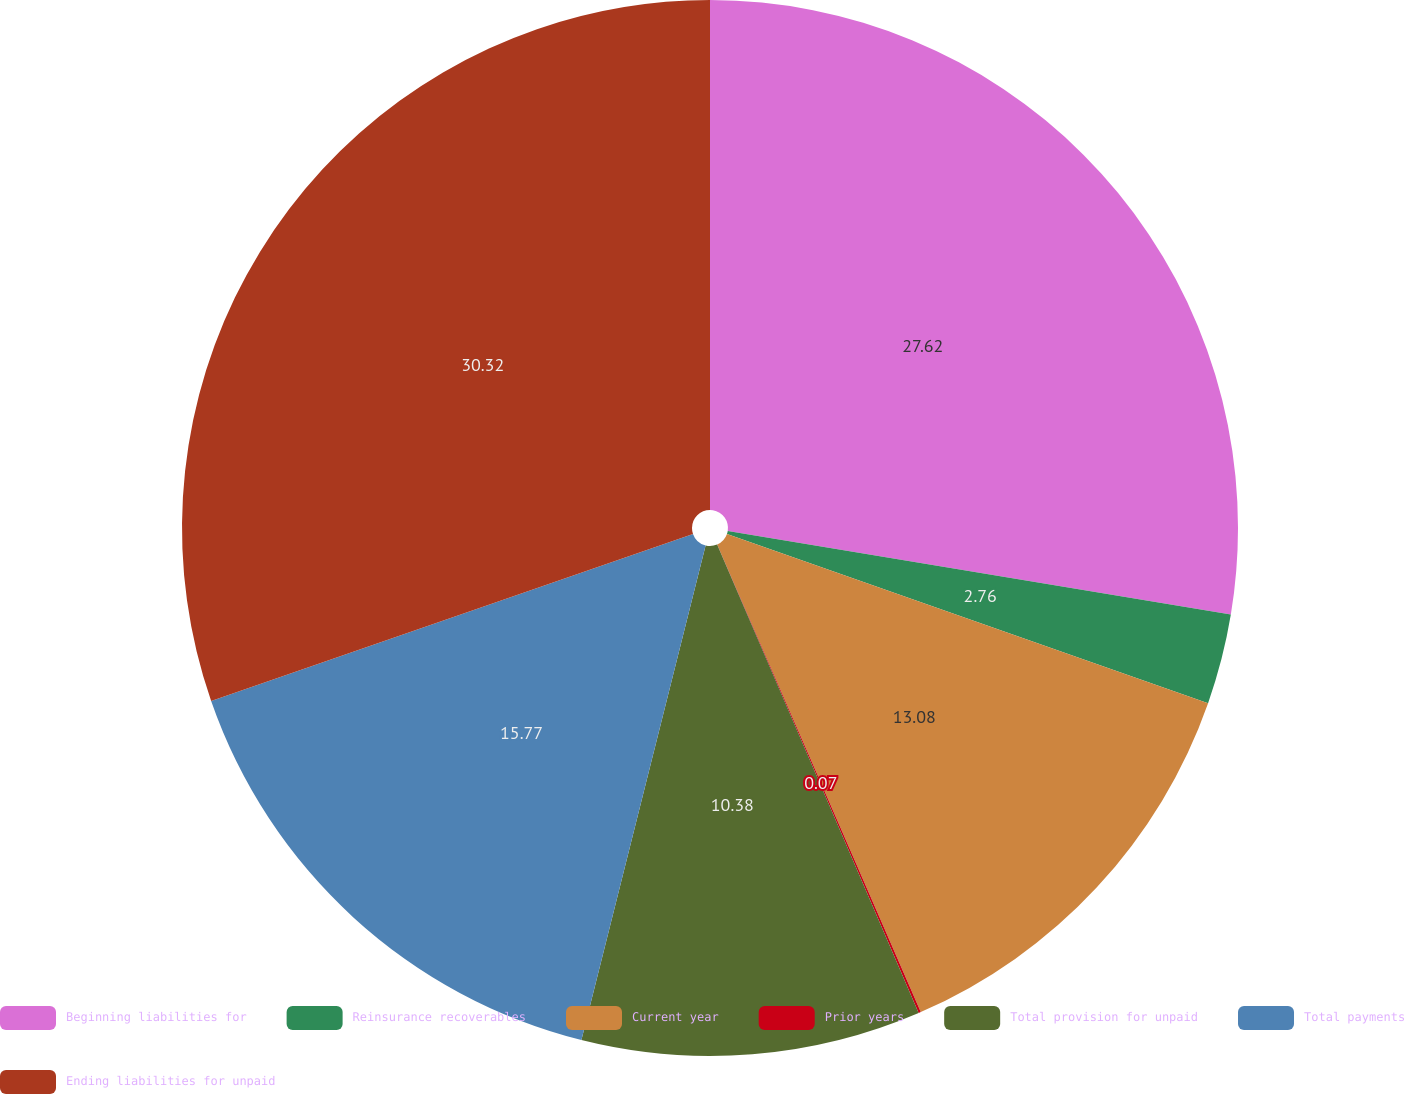<chart> <loc_0><loc_0><loc_500><loc_500><pie_chart><fcel>Beginning liabilities for<fcel>Reinsurance recoverables<fcel>Current year<fcel>Prior years<fcel>Total provision for unpaid<fcel>Total payments<fcel>Ending liabilities for unpaid<nl><fcel>27.62%<fcel>2.76%<fcel>13.08%<fcel>0.07%<fcel>10.38%<fcel>15.77%<fcel>30.31%<nl></chart> 